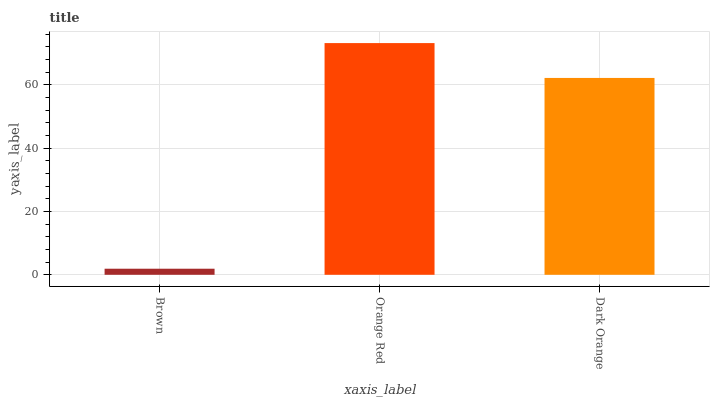Is Dark Orange the minimum?
Answer yes or no. No. Is Dark Orange the maximum?
Answer yes or no. No. Is Orange Red greater than Dark Orange?
Answer yes or no. Yes. Is Dark Orange less than Orange Red?
Answer yes or no. Yes. Is Dark Orange greater than Orange Red?
Answer yes or no. No. Is Orange Red less than Dark Orange?
Answer yes or no. No. Is Dark Orange the high median?
Answer yes or no. Yes. Is Dark Orange the low median?
Answer yes or no. Yes. Is Brown the high median?
Answer yes or no. No. Is Brown the low median?
Answer yes or no. No. 